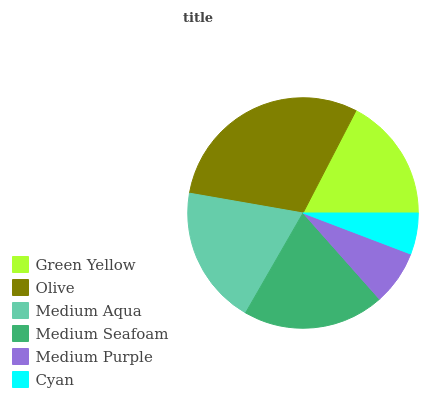Is Cyan the minimum?
Answer yes or no. Yes. Is Olive the maximum?
Answer yes or no. Yes. Is Medium Aqua the minimum?
Answer yes or no. No. Is Medium Aqua the maximum?
Answer yes or no. No. Is Olive greater than Medium Aqua?
Answer yes or no. Yes. Is Medium Aqua less than Olive?
Answer yes or no. Yes. Is Medium Aqua greater than Olive?
Answer yes or no. No. Is Olive less than Medium Aqua?
Answer yes or no. No. Is Medium Aqua the high median?
Answer yes or no. Yes. Is Green Yellow the low median?
Answer yes or no. Yes. Is Green Yellow the high median?
Answer yes or no. No. Is Cyan the low median?
Answer yes or no. No. 